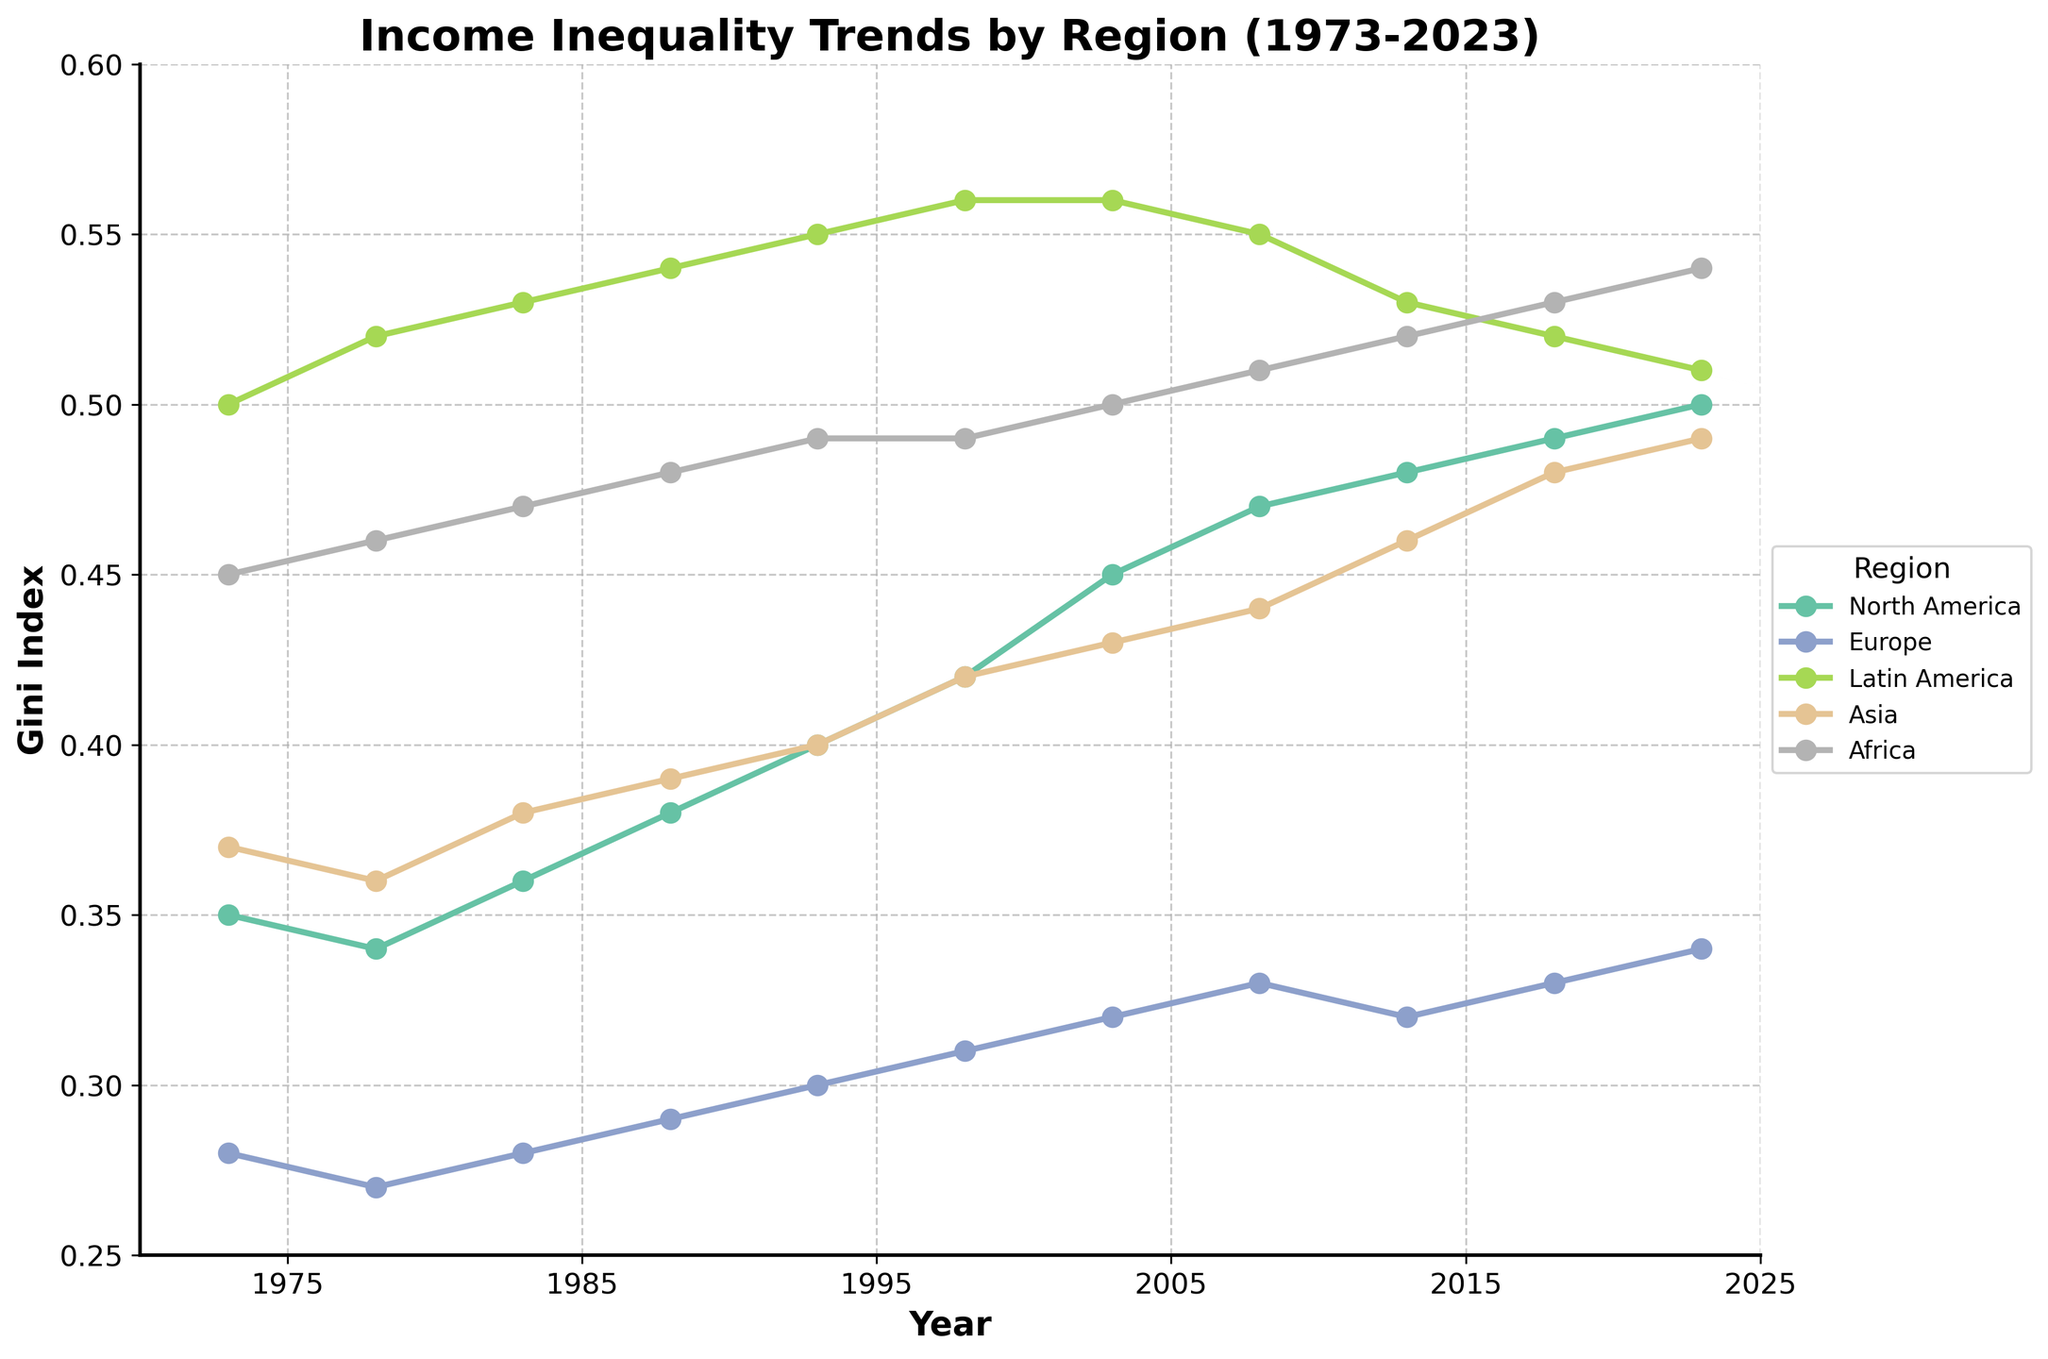What does the plot's title indicate? The title of the plot is located at the top. It provides a summary of what the plot represents, indicating that it shows 'Income Inequality Trends by Region' from 1973 to 2023.
Answer: Income Inequality Trends by Region (1973-2023) Which region had the highest Gini Index in 1973? By looking at the starting points of the lines in 1973, you can see that Latin America had the highest value on the y-axis.
Answer: Latin America What is the Gini Index value for North America in 2023? Find the point on the North America line that corresponds to the year 2023 on the x-axis, and see where it lands on the y-axis.
Answer: 0.50 Has the Gini Index in Europe ever been higher than in Asia? Comparing the lines for Europe and Asia over the years, you'll notice that the Gini Index for Europe has always been lower than for Asia.
Answer: No Between which years did North America see the sharpest increase in its Gini Index? Look at the North America line and see where the slope is steepest, which visually appears to be between 1993 and 2003.
Answer: 1993 to 2003 What is the average Gini Index for Africa between 2013 and 2023? Find the Gini Index values for Africa in 2013 (0.52), 2018 (0.53), and 2023 (0.54), sum them up, and divide by the number of years (3). (0.52 + 0.53 + 0.54) / 3 = 0.53
Answer: 0.53 Which region had the smallest overall change in Gini Index from 1973 to 2023? Calculate the difference between the starting and ending values for each line. Europe starts at 0.28 and ends at 0.34, making the change 0.06, which is the smallest compared to other regions.
Answer: Europe How has the Gini Index for Latin America changed from its highest point? Identify the highest point for Latin America, which is 0.56 (1998 and 2003), and note that in 2023, it's 0.51. Thus, the decrease is 0.56 - 0.51 = 0.05.
Answer: Decreased by 0.05 Which region has generally experienced an upward trend from 1973 to 2023? By looking at the trajectory of each line, you see that all regions except Latin America have an upward trend overall.
Answer: All except Latin America Which two regions had the most similar Gini Index values in 2023? Compare the final points of each line in 2023. North America and Asia both have very close Gini Index values around 0.50 and 0.49, respectively.
Answer: North America and Asia 